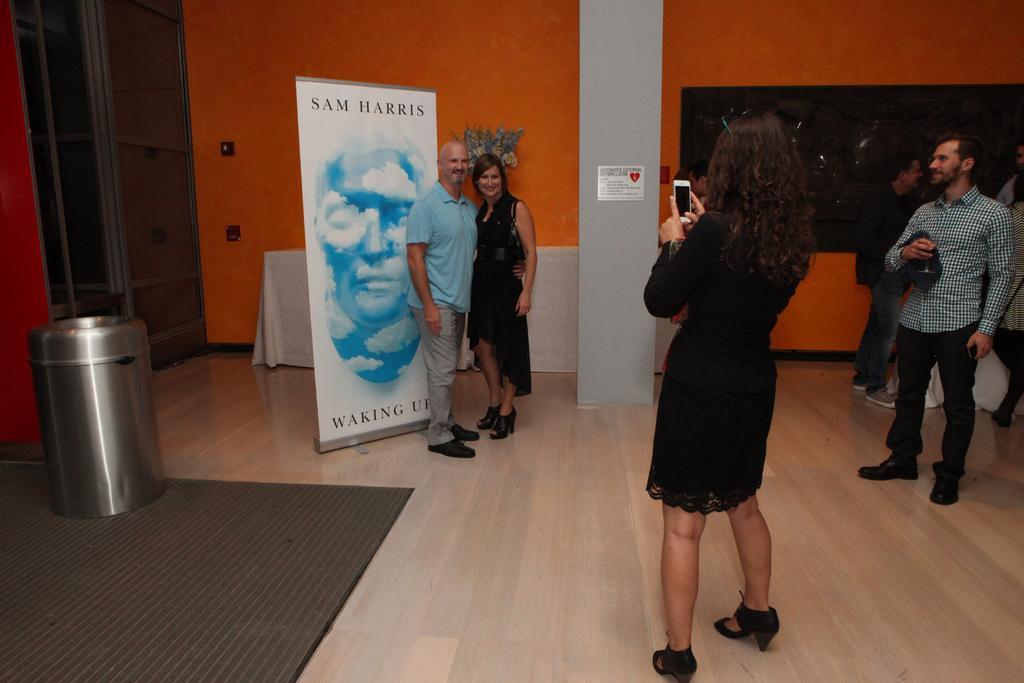Please provide a concise description of this image. In this image we can see this person wearing black dress is holding a mobile phone and standing here. Here we can see these two persons are standing near the banner, we can see the trash can, table upon which we can see flower vase is kept, we can see the pillar and in the background, we can see the orange color wall. 